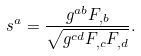<formula> <loc_0><loc_0><loc_500><loc_500>s ^ { a } = \frac { g ^ { a b } F _ { , b } } { \sqrt { g ^ { c d } F _ { , c } F _ { , d } } } .</formula> 